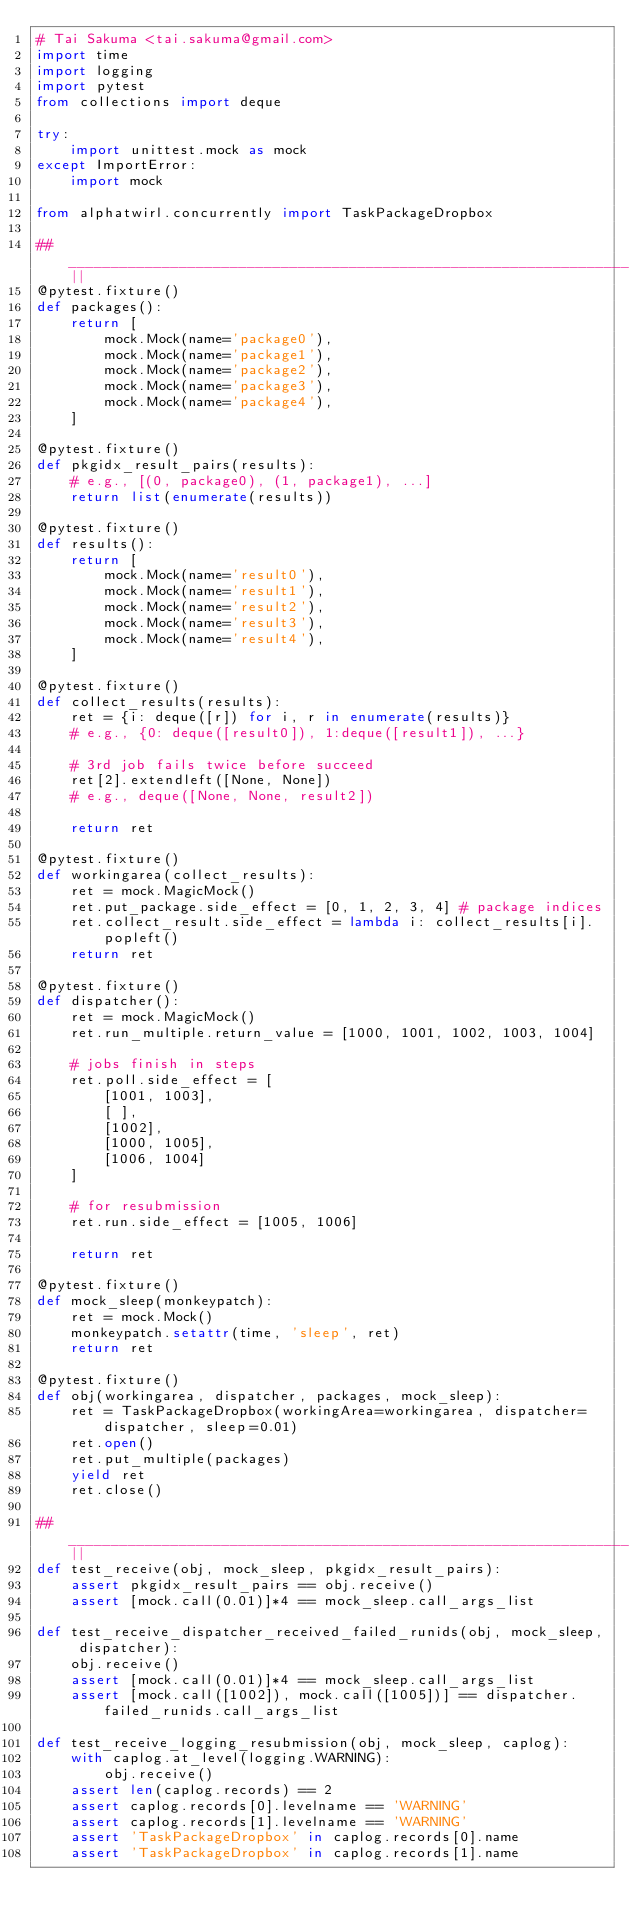<code> <loc_0><loc_0><loc_500><loc_500><_Python_># Tai Sakuma <tai.sakuma@gmail.com>
import time
import logging
import pytest
from collections import deque

try:
    import unittest.mock as mock
except ImportError:
    import mock

from alphatwirl.concurrently import TaskPackageDropbox

##__________________________________________________________________||
@pytest.fixture()
def packages():
    return [
        mock.Mock(name='package0'),
        mock.Mock(name='package1'),
        mock.Mock(name='package2'),
        mock.Mock(name='package3'),
        mock.Mock(name='package4'),
    ]

@pytest.fixture()
def pkgidx_result_pairs(results):
    # e.g., [(0, package0), (1, package1), ...]
    return list(enumerate(results))

@pytest.fixture()
def results():
    return [
        mock.Mock(name='result0'),
        mock.Mock(name='result1'),
        mock.Mock(name='result2'),
        mock.Mock(name='result3'),
        mock.Mock(name='result4'),
    ]

@pytest.fixture()
def collect_results(results):
    ret = {i: deque([r]) for i, r in enumerate(results)}
    # e.g., {0: deque([result0]), 1:deque([result1]), ...}

    # 3rd job fails twice before succeed
    ret[2].extendleft([None, None])
    # e.g., deque([None, None, result2])

    return ret

@pytest.fixture()
def workingarea(collect_results):
    ret = mock.MagicMock()
    ret.put_package.side_effect = [0, 1, 2, 3, 4] # package indices
    ret.collect_result.side_effect = lambda i: collect_results[i].popleft()
    return ret

@pytest.fixture()
def dispatcher():
    ret = mock.MagicMock()
    ret.run_multiple.return_value = [1000, 1001, 1002, 1003, 1004]

    # jobs finish in steps
    ret.poll.side_effect = [
        [1001, 1003],
        [ ],
        [1002],
        [1000, 1005],
        [1006, 1004]
    ]

    # for resubmission
    ret.run.side_effect = [1005, 1006]

    return ret

@pytest.fixture()
def mock_sleep(monkeypatch):
    ret = mock.Mock()
    monkeypatch.setattr(time, 'sleep', ret)
    return ret

@pytest.fixture()
def obj(workingarea, dispatcher, packages, mock_sleep):
    ret = TaskPackageDropbox(workingArea=workingarea, dispatcher=dispatcher, sleep=0.01)
    ret.open()
    ret.put_multiple(packages)
    yield ret
    ret.close()

##__________________________________________________________________||
def test_receive(obj, mock_sleep, pkgidx_result_pairs):
    assert pkgidx_result_pairs == obj.receive()
    assert [mock.call(0.01)]*4 == mock_sleep.call_args_list

def test_receive_dispatcher_received_failed_runids(obj, mock_sleep, dispatcher):
    obj.receive()
    assert [mock.call(0.01)]*4 == mock_sleep.call_args_list
    assert [mock.call([1002]), mock.call([1005])] == dispatcher.failed_runids.call_args_list

def test_receive_logging_resubmission(obj, mock_sleep, caplog):
    with caplog.at_level(logging.WARNING):
        obj.receive()
    assert len(caplog.records) == 2
    assert caplog.records[0].levelname == 'WARNING'
    assert caplog.records[1].levelname == 'WARNING'
    assert 'TaskPackageDropbox' in caplog.records[0].name
    assert 'TaskPackageDropbox' in caplog.records[1].name</code> 